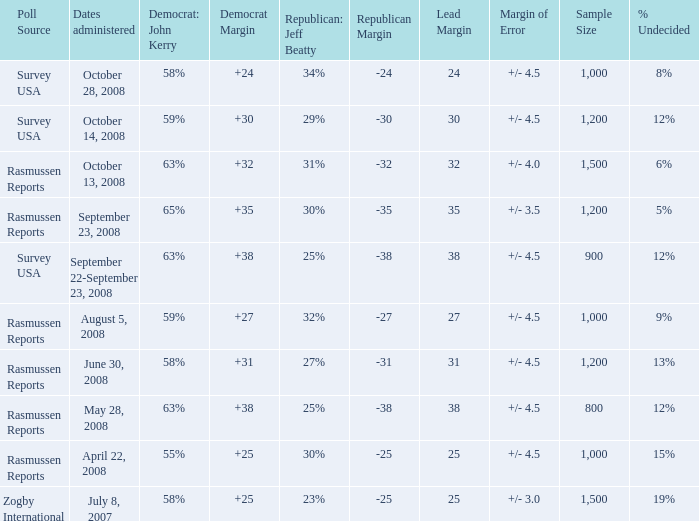Who is the poll source that has Republican: Jeff Beatty behind at 27%? Rasmussen Reports. 